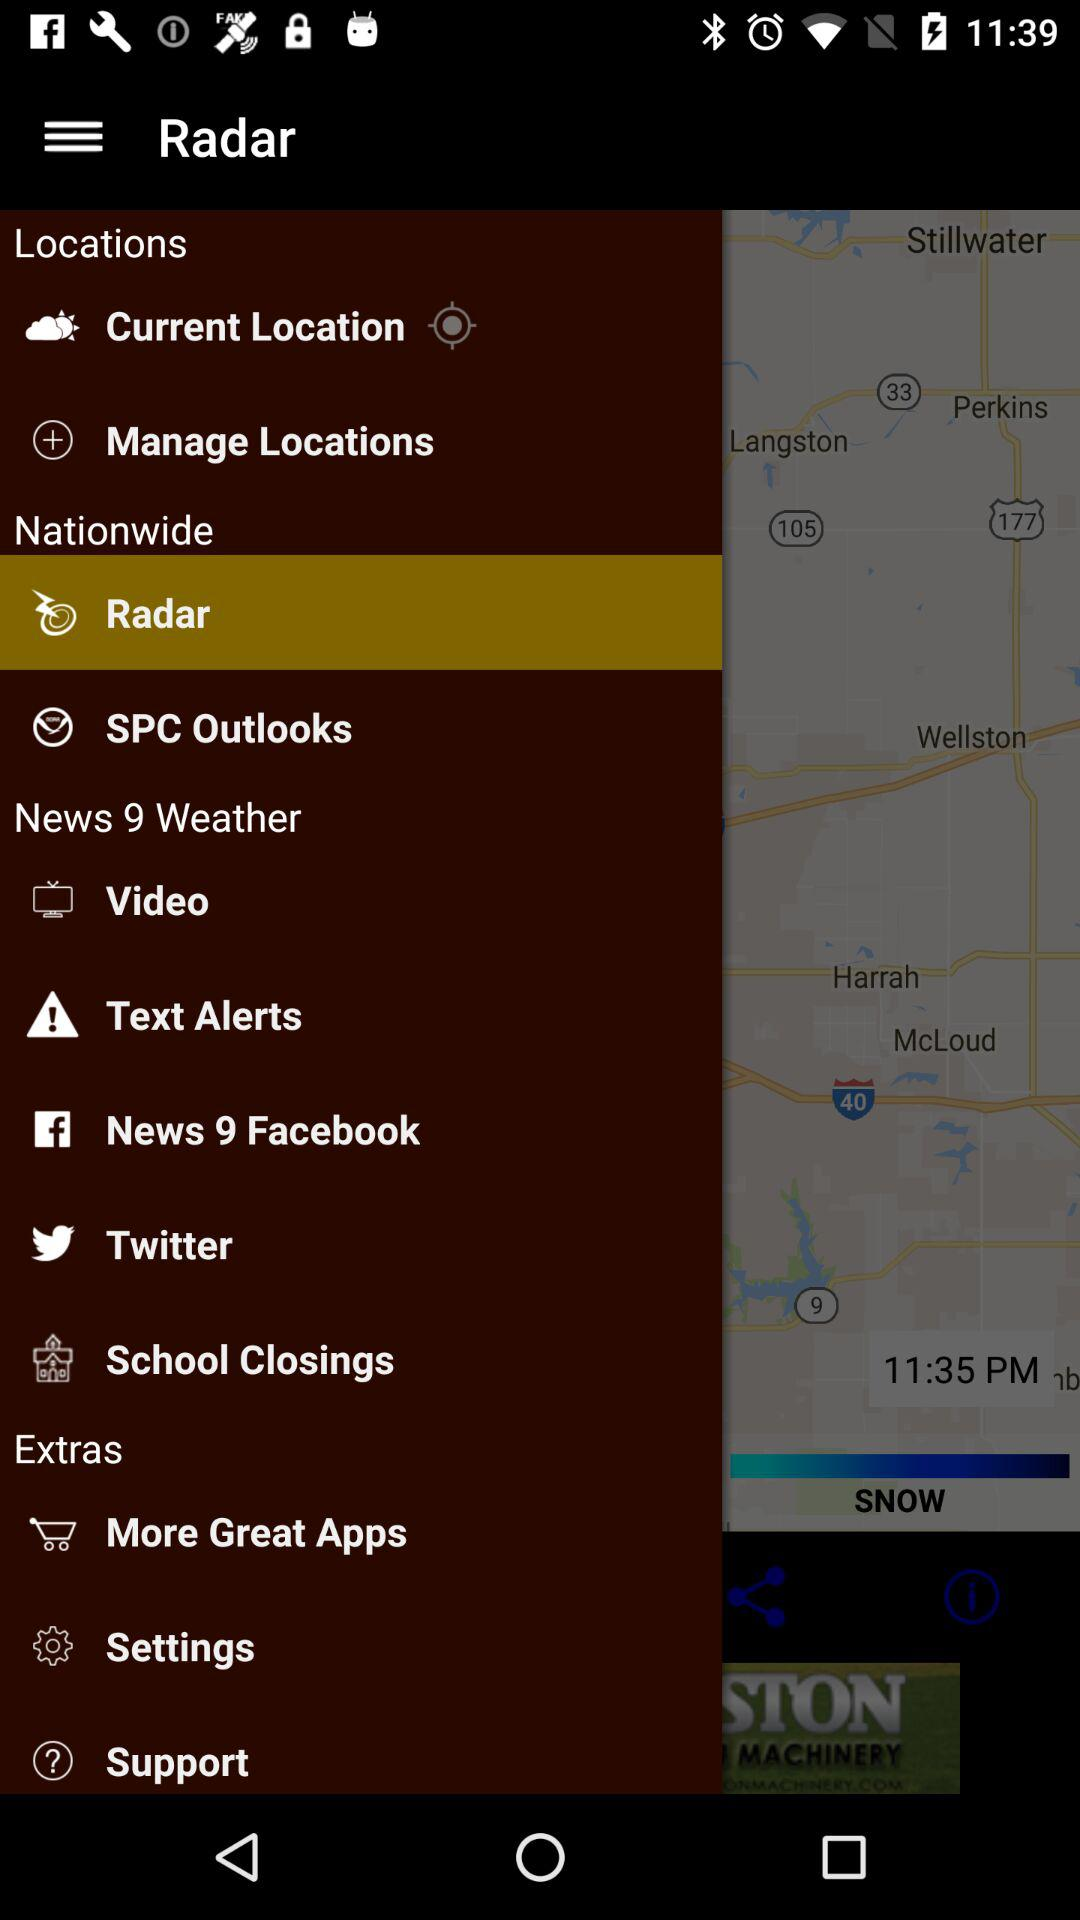What option is selected? The selected option is "Radar". 